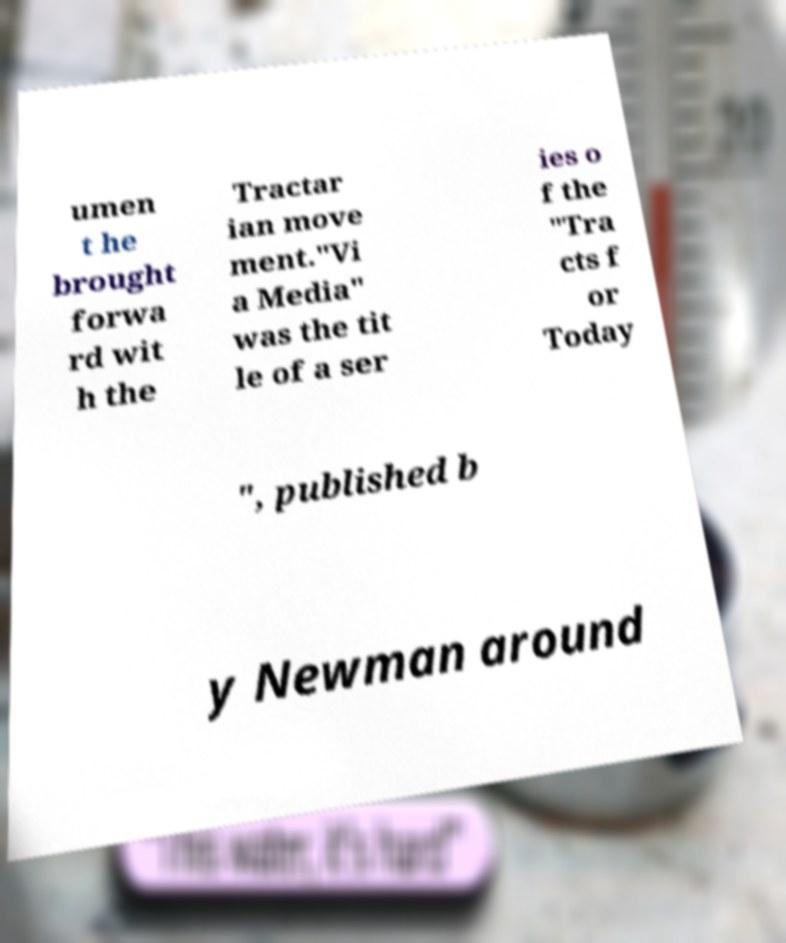I need the written content from this picture converted into text. Can you do that? umen t he brought forwa rd wit h the Tractar ian move ment."Vi a Media" was the tit le of a ser ies o f the "Tra cts f or Today ", published b y Newman around 